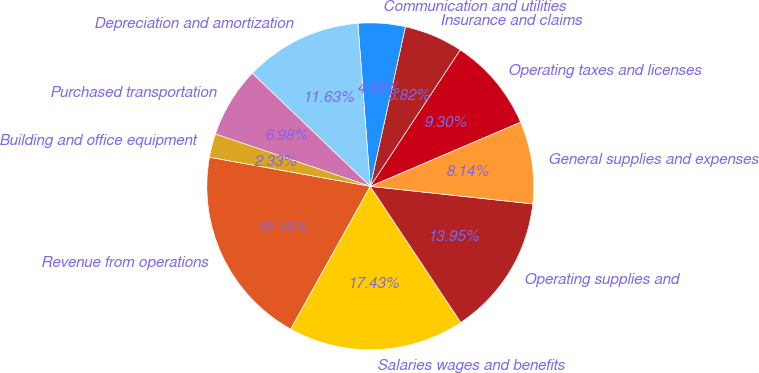<chart> <loc_0><loc_0><loc_500><loc_500><pie_chart><fcel>Revenue from operations<fcel>Salaries wages and benefits<fcel>Operating supplies and<fcel>General supplies and expenses<fcel>Operating taxes and licenses<fcel>Insurance and claims<fcel>Communication and utilities<fcel>Depreciation and amortization<fcel>Purchased transportation<fcel>Building and office equipment<nl><fcel>19.76%<fcel>17.43%<fcel>13.95%<fcel>8.14%<fcel>9.3%<fcel>5.82%<fcel>4.66%<fcel>11.63%<fcel>6.98%<fcel>2.33%<nl></chart> 